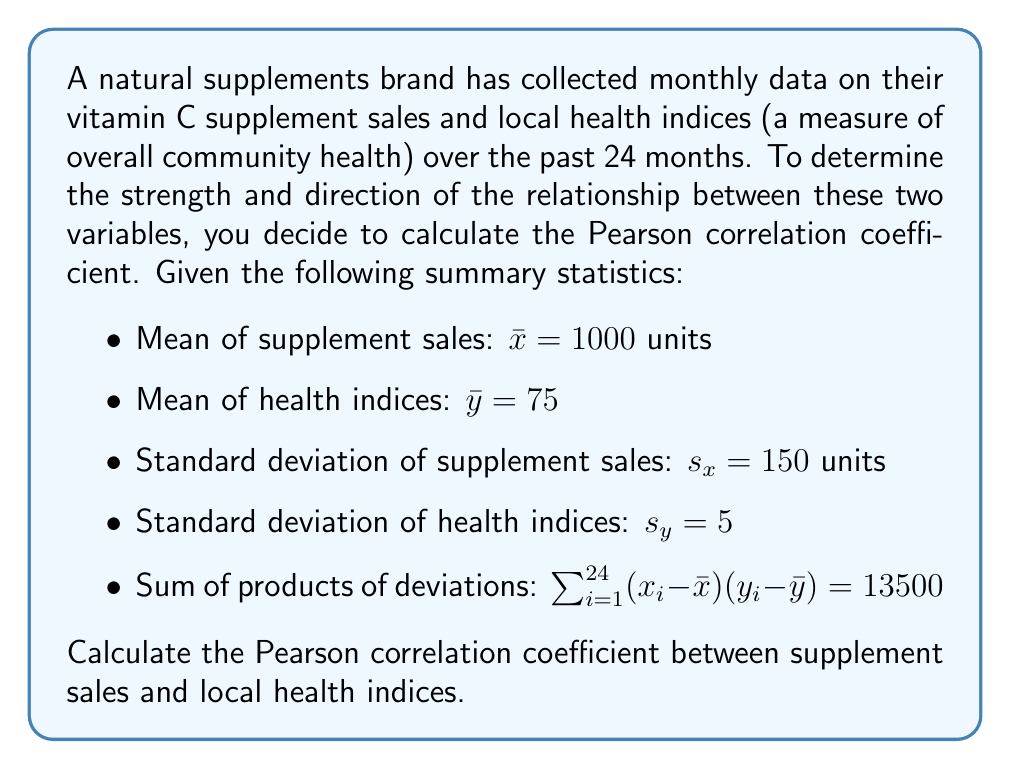Could you help me with this problem? To calculate the Pearson correlation coefficient (r), we'll use the formula:

$$ r = \frac{\sum_{i=1}^{n} (x_i - \bar{x})(y_i - \bar{y})}{(n-1)s_x s_y} $$

Where:
- $n$ is the number of data points (24 months)
- $\sum_{i=1}^{n} (x_i - \bar{x})(y_i - \bar{y})$ is the sum of products of deviations (given as 13500)
- $s_x$ and $s_y$ are the standard deviations of x and y respectively

Let's substitute the values into the formula:

$$ r = \frac{13500}{(24-1) \cdot 150 \cdot 5} $$

$$ r = \frac{13500}{23 \cdot 150 \cdot 5} $$

$$ r = \frac{13500}{17250} $$

$$ r \approx 0.7826 $$

The Pearson correlation coefficient ranges from -1 to 1, where:
- 1 indicates a perfect positive linear relationship
- -1 indicates a perfect negative linear relationship
- 0 indicates no linear relationship

Our result of approximately 0.7826 suggests a strong positive correlation between supplement sales and local health indices.
Answer: $r \approx 0.7826$ 